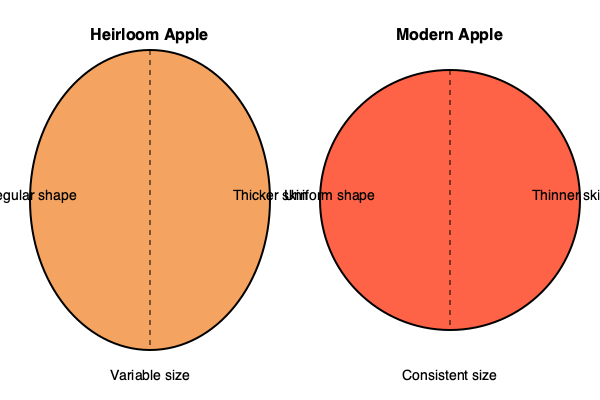Based on the diagram, identify three key structural differences between heirloom and modern apple cultivars that could impact their culinary applications. 1. Shape:
   - Heirloom apples typically have an irregular shape, as shown by the elliptical form in the diagram.
   - Modern apple cultivars have a more uniform, circular shape.
   - Culinary impact: Irregular shapes in heirloom apples may affect presentation and cutting techniques.

2. Size:
   - Heirloom apples are depicted with "Variable size" in the diagram.
   - Modern apples are labeled as having "Consistent size".
   - Culinary impact: Variable sizes in heirloom apples may require adjustments in recipes and cooking times.

3. Skin thickness:
   - The diagram indicates that heirloom apples have a "Thicker skin".
   - Modern apple cultivars are shown to have a "Thinner skin".
   - Culinary impact: Thicker skin in heirloom apples may affect texture in raw applications and cooking methods.

These structural differences can significantly influence the culinary uses of heirloom apples compared to modern cultivars, affecting aspects such as preparation techniques, cooking times, and flavor profiles in various dishes.
Answer: Shape irregularity, size variability, and skin thickness 